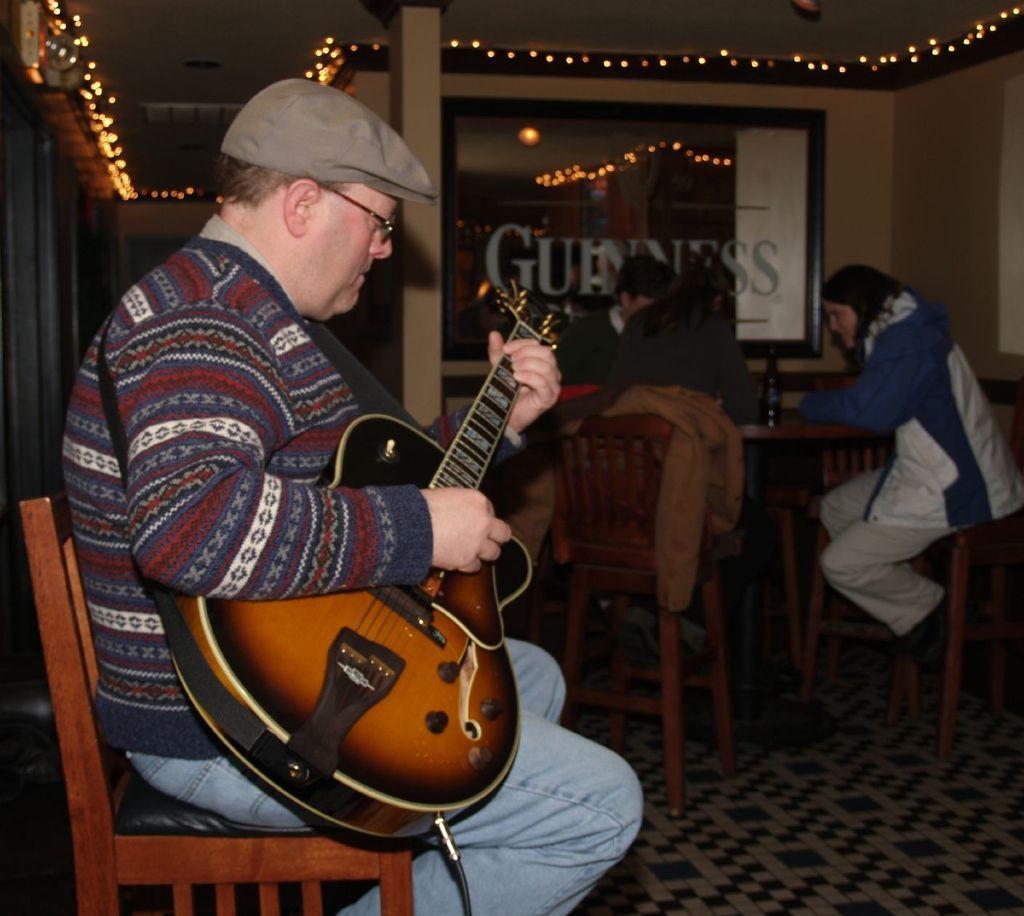In one or two sentences, can you explain what this image depicts? There is a man sitting on a bench in the foreground area of the image, by holding a guitar in his hands, there are people, light, it seems like a glass window in the background. 